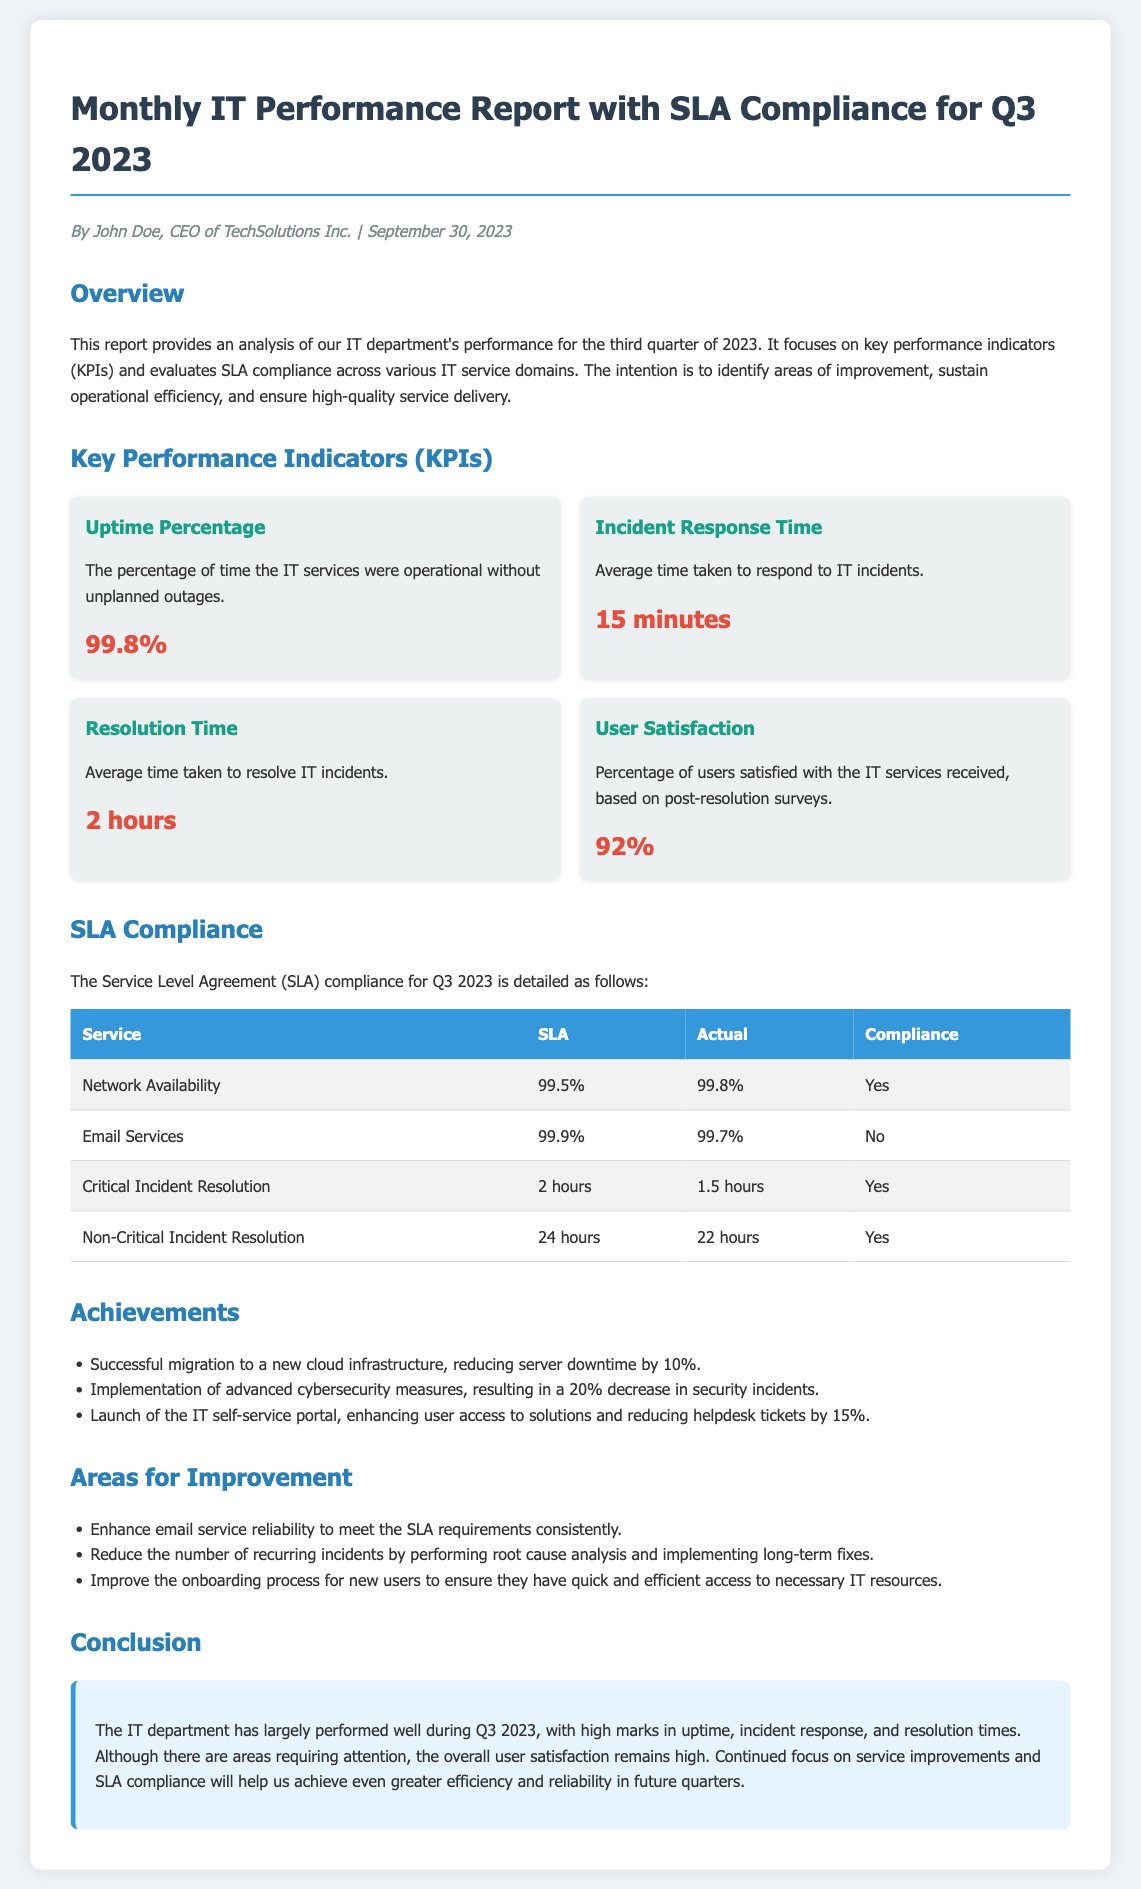What is the uptime percentage for Q3 2023? The uptime percentage is a key performance indicator (KPI) reflecting the operational time without outages, indicated in the document as 99.8%.
Answer: 99.8% What is the average incident response time? The average incident response time indicates how quickly incidents are addressed, specified in the document as 15 minutes.
Answer: 15 minutes How many areas for improvement are listed in the report? The report includes a section that outlines specific areas needing enhancement, with three areas mentioned.
Answer: 3 What was the SLA compliance for Network Availability? The SLA for Network Availability is detailed in the compliance section of the document, where the actual performance was 99.8%, indicating compliance.
Answer: Yes What was the user satisfaction rate according to the report? The document states that user satisfaction is based on surveys, and the percentage reported is 92%.
Answer: 92% What is the conclusion about the IT department's performance in Q3 2023? The conclusion summarizes the overall performance evaluations, highlighting strengths and areas of attention. It reflects a positive outlook despite areas for improvement.
Answer: Largely performed well What was the SLA for Email Services, and was it met? The SLA for Email Services is listed in the compliance table, which indicates the actual performance was below the SLA threshold, therefore it was not met.
Answer: No What percentage decrease in security incidents resulted from the new cybersecurity measures? The document highlights the successful implementation of cybersecurity measures, which led to a notable reduction in incidents quantified as 20%.
Answer: 20% How many minutes does it take to resolve IT incidents on average? The average resolution time for IT incidents is specified within the key performance indicators, noted as 2 hours.
Answer: 2 hours 